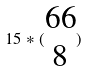Convert formula to latex. <formula><loc_0><loc_0><loc_500><loc_500>1 5 * ( \begin{matrix} 6 6 \\ 8 \end{matrix} )</formula> 